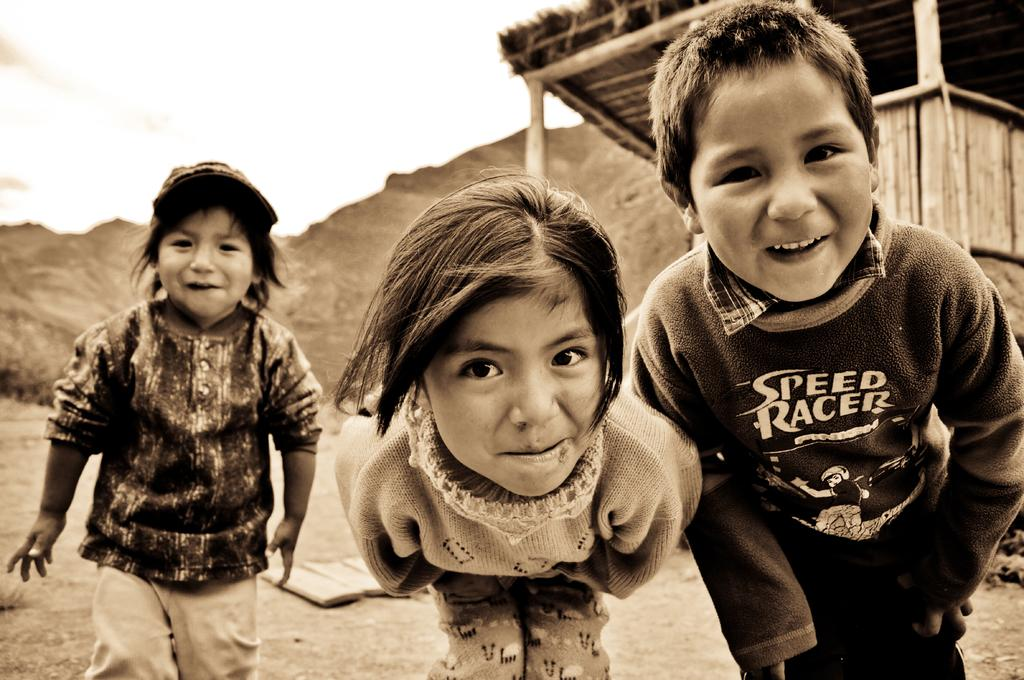How many children are visible in the image? There are 3 children in the front of the image. What type of structure can be seen in the image? There is a shack in the image. What natural feature is visible in the background of the image? There are mountains in the background of the image. What is visible at the top of the image? The sky is visible at the top of the image. What type of wrist accessory is worn by the children in the image? There is no information about any wrist accessories worn by the children in the image. 